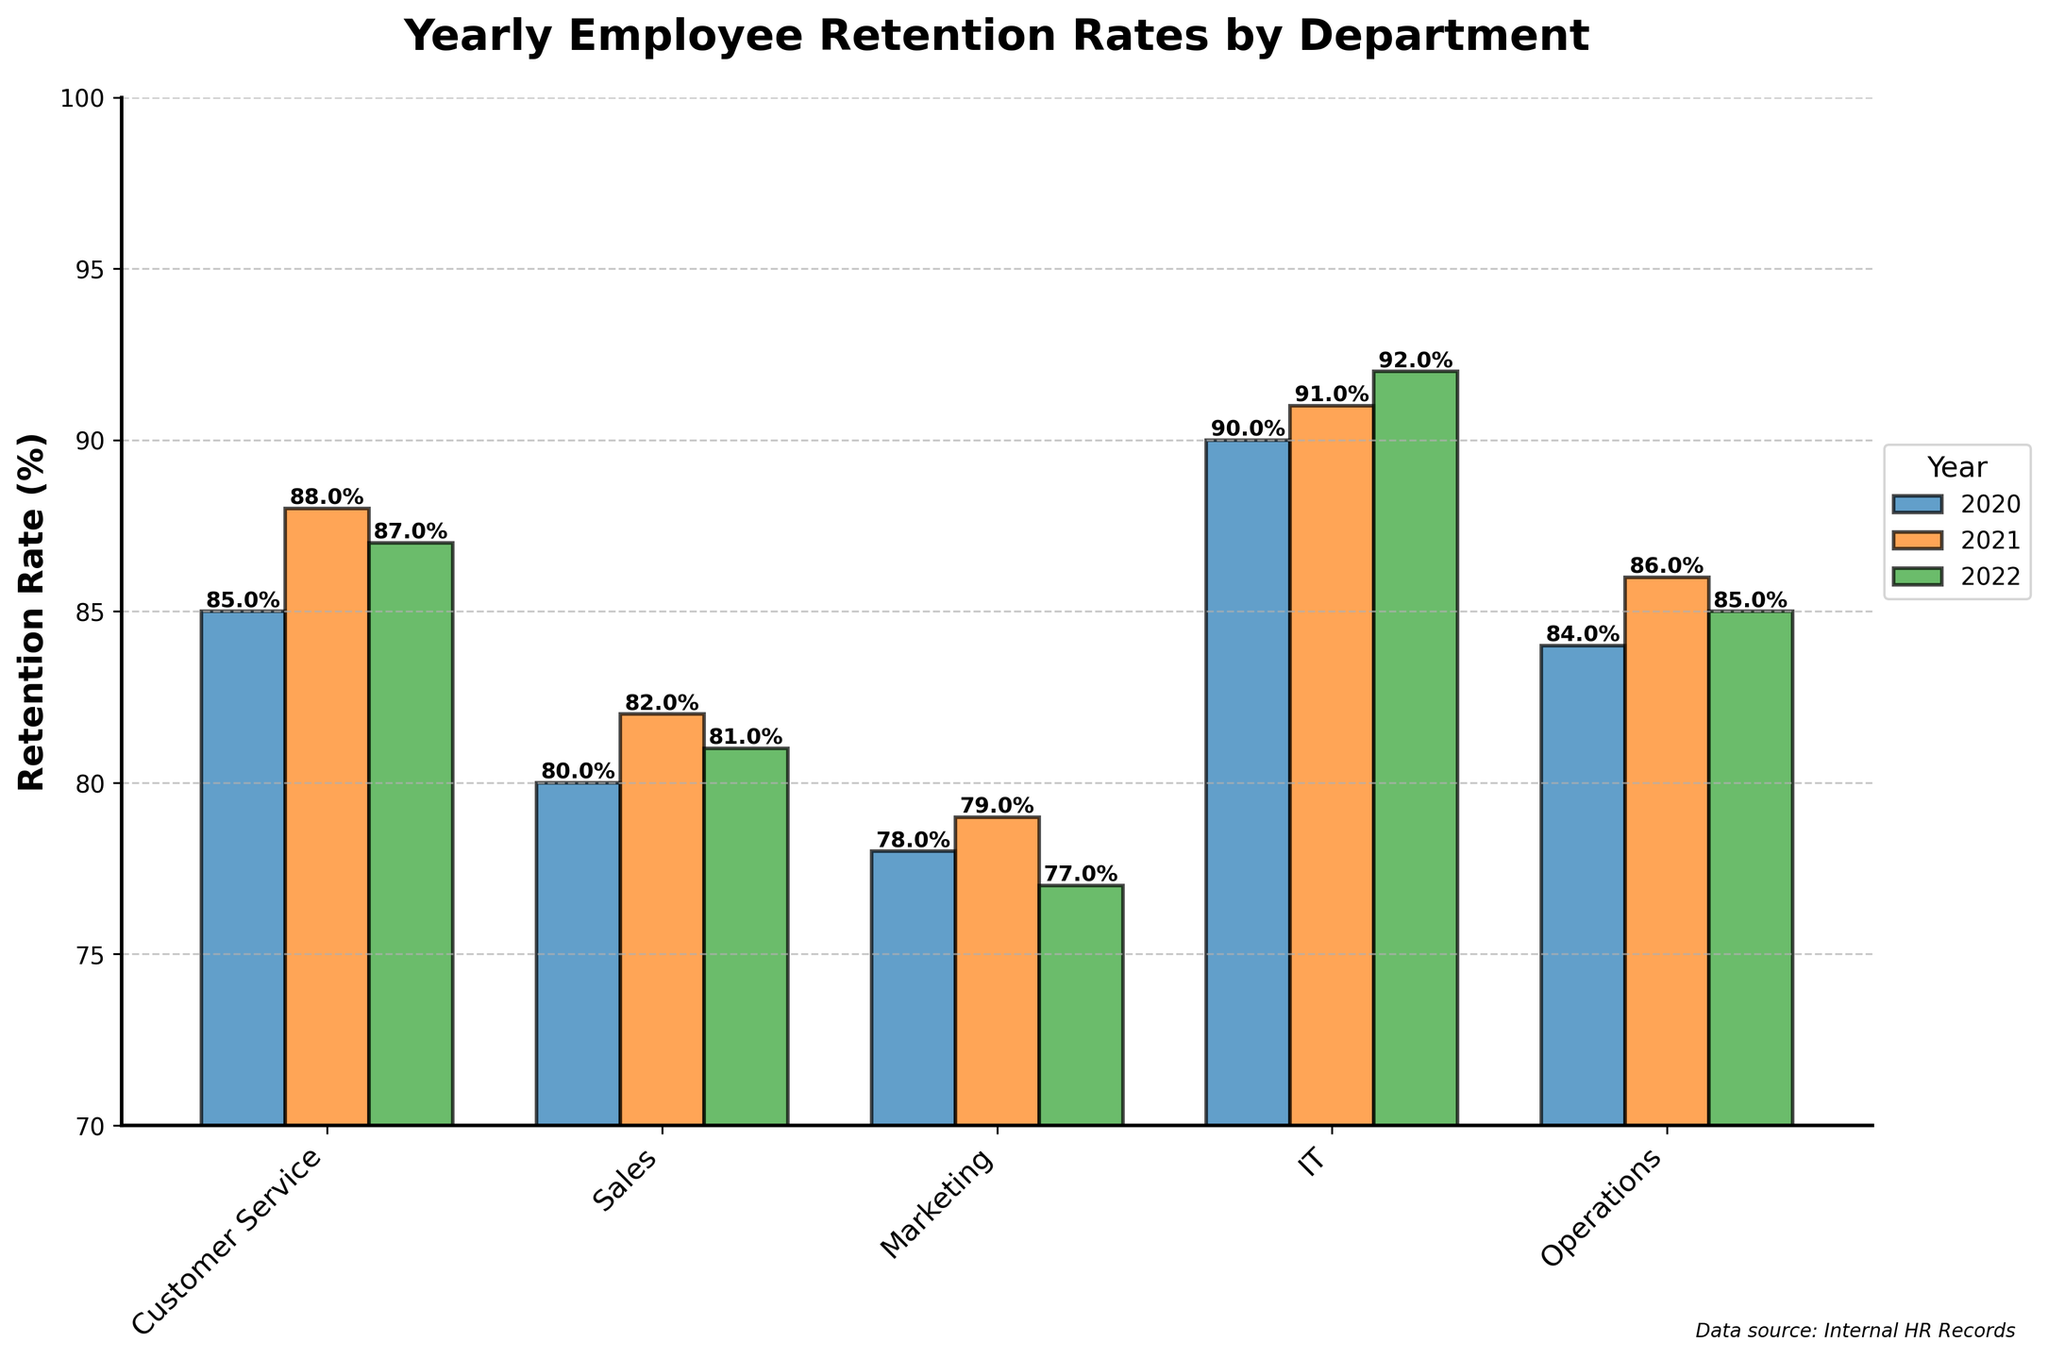What is the retention rate for the Customer Service department in 2021? The retention rate for the Customer Service department in 2021 is shown by the height of the bar labeled '2021' under the Customer Service category.
Answer: 88% Which department had the highest retention rate in 2022? Check the bar heights for each department in 2022. The IT department has the tallest bar, indicating the highest retention rate.
Answer: IT What is the average retention rate for the Sales department from 2020 to 2022? Add the retention rates for the Sales department over the years 2020, 2021, and 2022 (80%, 82%, 81%) and divide by 3 to find the average. (80 + 82 + 81) / 3 = 81%
Answer: 81% Which department showed the most significant improvement in retention rate from 2020 to 2021? Compare the differences in retention rates between 2020 and 2021 for each department. For Customer Service (88 - 85 = 3%), Sales (82 - 80 = 2%), Marketing (79 - 78 = 1%), IT (91 - 90 = 1%), and Operations (86 - 84 = 2%), Customer Service shows the largest improvement of 3%.
Answer: Customer Service How does the margin of error for the Operations department in 2022 compare to that of the Sales department in 2021? The margin of error for the Operations department in 2022 is 2.5%, and for the Sales department in 2021, it is 3.5%. Hence, the margin of error for Operations in 2022 is less than for Sales in 2021.
Answer: Less than What is the range of retention rates for the IT department from 2020 to 2022? Find the minimum and maximum retention rates for the IT department over the years. The minimum is 90% (2020) and the maximum is 92% (2022), thus the range is 92% - 90% = 2%.
Answer: 2% Did any department experience a decrease in retention rate from 2021 to 2022? Check the change in retention rates from 2021 to 2022 for each department. Marketing decreased from 79% to 77%.
Answer: Marketing What is the sum of the retention rates for the Marketing department over the three years? Add the retention rates for the Marketing department across 2020, 2021, and 2022. (78 + 79 + 77) = 234%
Answer: 234% Which year had the overall highest retention rates across all departments? Compare the retention rates for all departments in each year. Summing up for each year, 2020: 85+80+78+90+84 = 417%, 2021: 88+82+79+91+86 = 426%, 2022: 87+81+77+92+85 = 422%. The year 2021 has the highest total retention rates.
Answer: 2021 What is the difference in error margins for the Customer Service department between 2020 and 2022? Subtract the margin of error in 2022 (2%) from that in 2020 (3%). 3% - 2% = 1%
Answer: 1% 